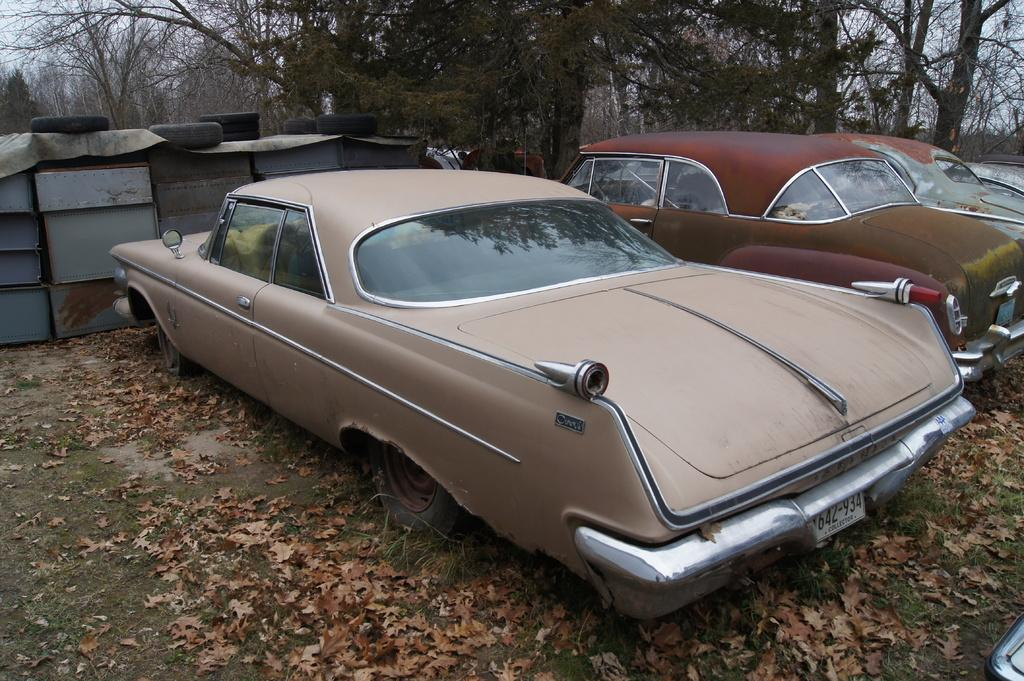What is parked on the ground in the image? There are cars parked on the ground in the image. What type of vegetation can be seen on the ground in the image? Dry leaves and grass are visible in the image. What part of the cars can be seen in the image? Tires are visible in the image. What is visible in the background of the image? Trees are present in the background of the image. What is the price of the card and cloth in the image? There is no card or cloth present in the image, so it is not possible to determine their price. 